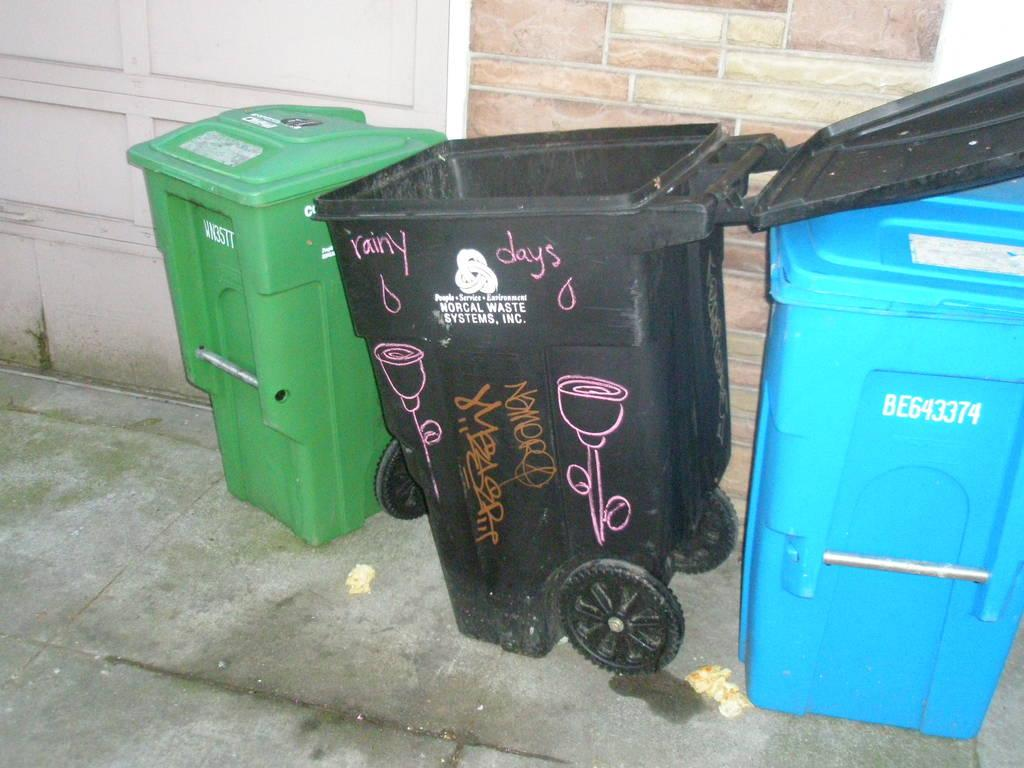<image>
Describe the image concisely. A black trash can reads "rainy days" on the side. 